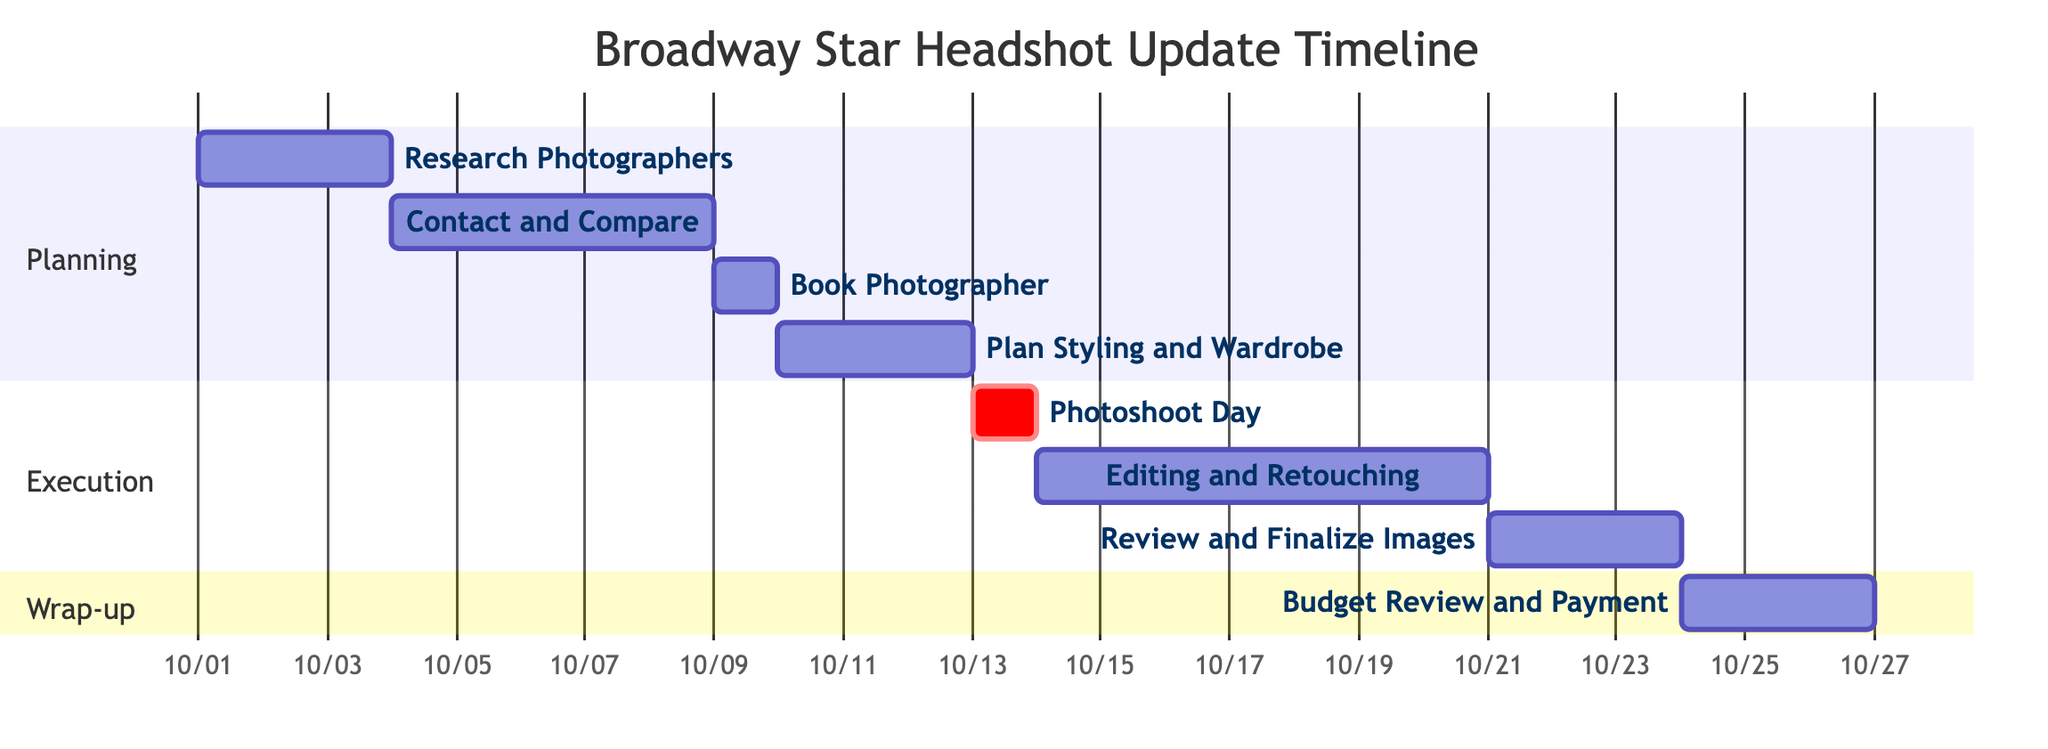What is the duration of the "Photoshoot Day"? The Gantt chart shows "Photoshoot Day" with a duration of "1 day." This information is clearly visible underneath the task name in the task row.
Answer: 1 day What task comes after "Contact and Compare Photographers"? By following the dependency arrows in the Gantt chart, after "Contact and Compare Photographers," the next task is "Book Photographer," which is shown to occur immediately afterward.
Answer: Book Photographer How many total tasks are there in the project? Counting the individual task elements listed in the Gantt chart, there are a total of 8 distinct tasks shown in the sections provided (Planning, Execution, and Wrap-up).
Answer: 8 What is the start date of the "Editing and Retouching" task? The Gantt chart specifies that "Editing and Retouching" begins on "2023-10-14." This is found in the task row details of the chart.
Answer: 2023-10-14 Which task is critical in the execution phase? The diagram highlights "Photoshoot Day" as critical, indicated by the "crit" label next to the task name, signifying its importance in the timeline.
Answer: Photoshoot Day What is the end date of the "Budget Review and Payment" task? Looking at the Gantt chart, "Budget Review and Payment" concludes on "2023-10-26." This end date is marked at the end of that specific task row.
Answer: 2023-10-26 How many days does "Editing and Retouching" span? The Gantt chart shows that "Editing and Retouching" lasts for "7 days," starting from the end of "Photoshoot Day" and spanning over the stated period in the task row.
Answer: 7 days What is the dependency for the "Plan Styling and Wardrobe" task? The Gantt chart illustrates that "Plan Styling and Wardrobe" is dependent on the task before it, which is "Book Photographer." This is indicated by the dependency arrow leading into the "Plan Styling and Wardrobe" task.
Answer: Book Photographer What is the section title for the last phase of tasks? The final phase of tasks is titled "Wrap-up," as clearly labeled in the Gantt chart structure above the listed tasks for that phase.
Answer: Wrap-up 